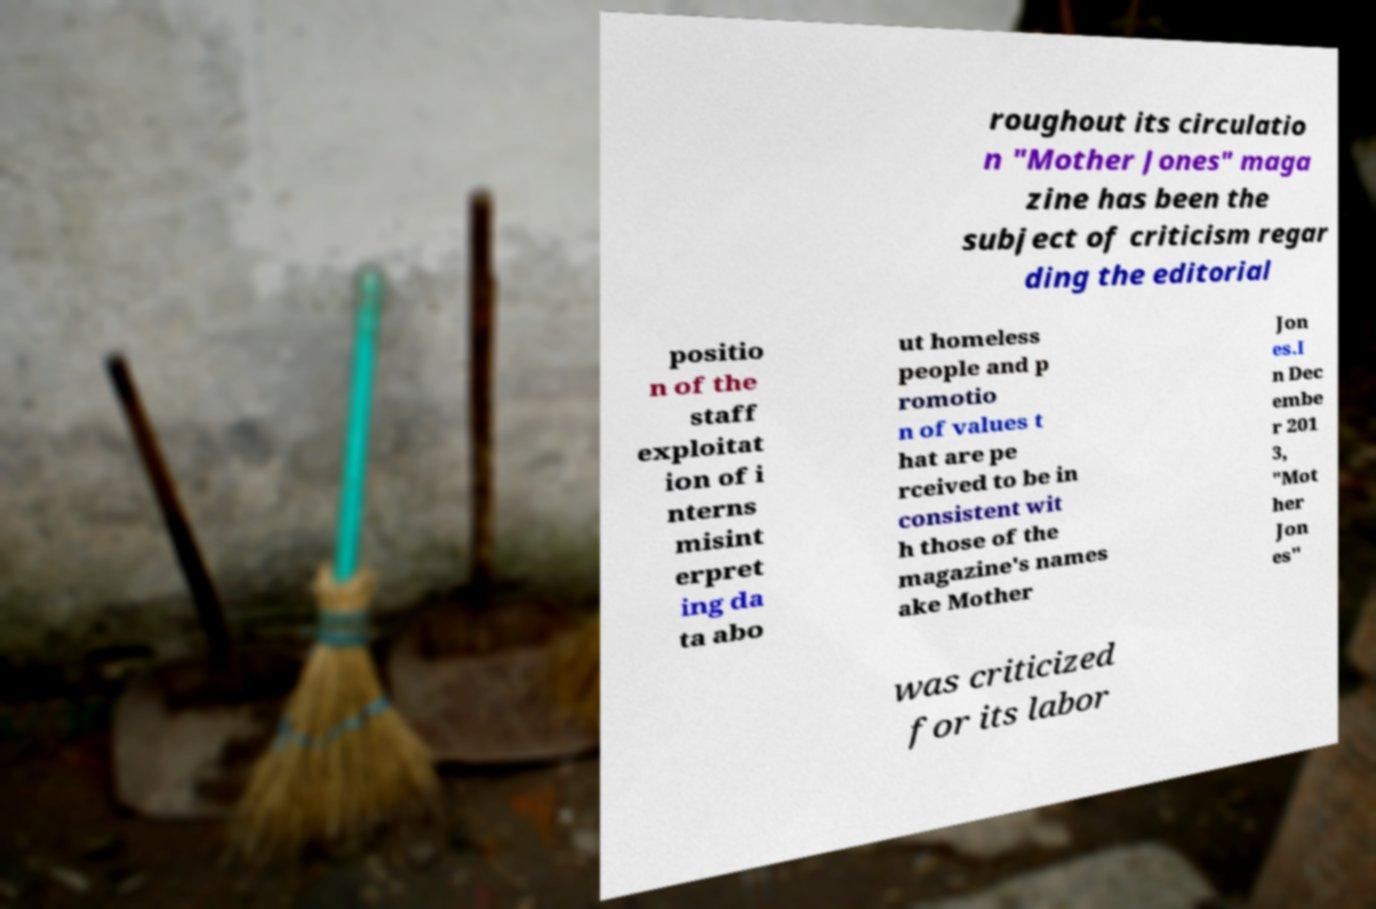For documentation purposes, I need the text within this image transcribed. Could you provide that? roughout its circulatio n "Mother Jones" maga zine has been the subject of criticism regar ding the editorial positio n of the staff exploitat ion of i nterns misint erpret ing da ta abo ut homeless people and p romotio n of values t hat are pe rceived to be in consistent wit h those of the magazine's names ake Mother Jon es.I n Dec embe r 201 3, "Mot her Jon es" was criticized for its labor 